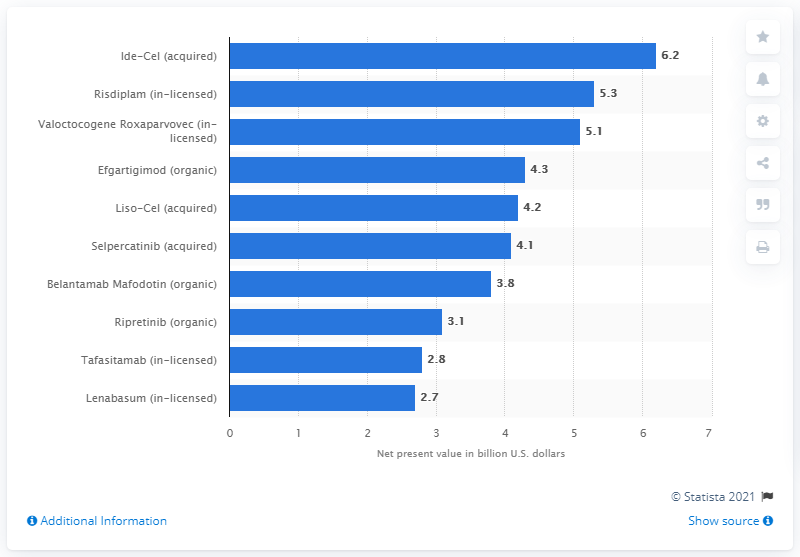Highlight a few significant elements in this photo. As of 2020, the net present value of Ide-Cel was 6.2. 